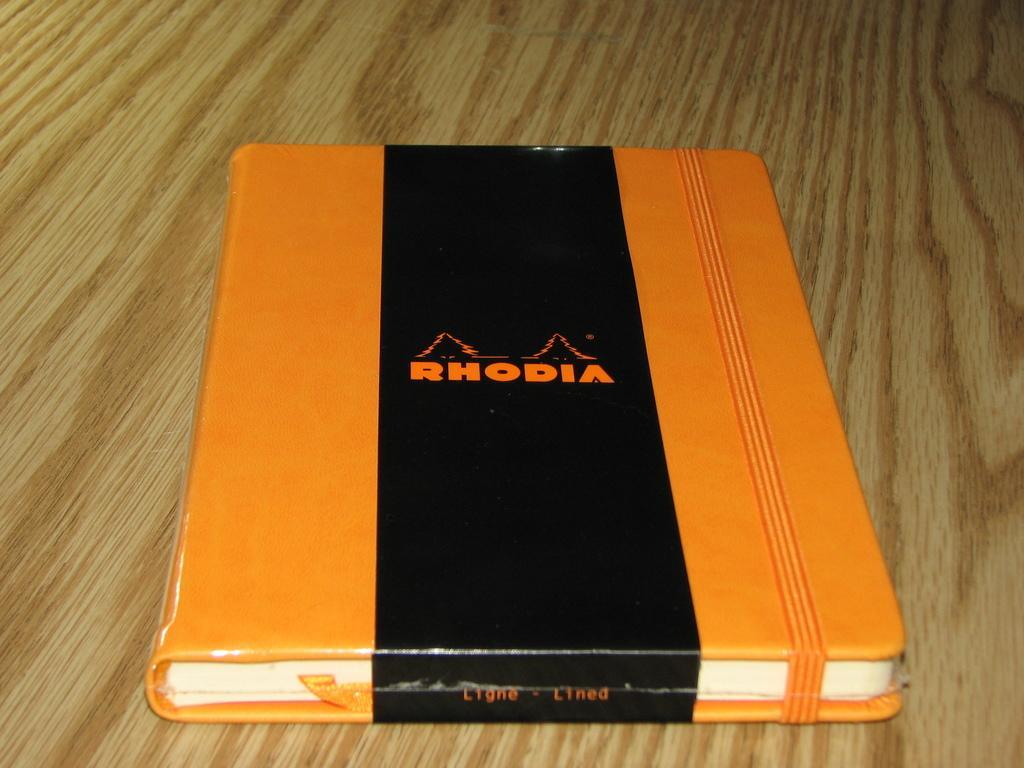<image>
Offer a succinct explanation of the picture presented. A book with the title Rhodia sitting on a table. 